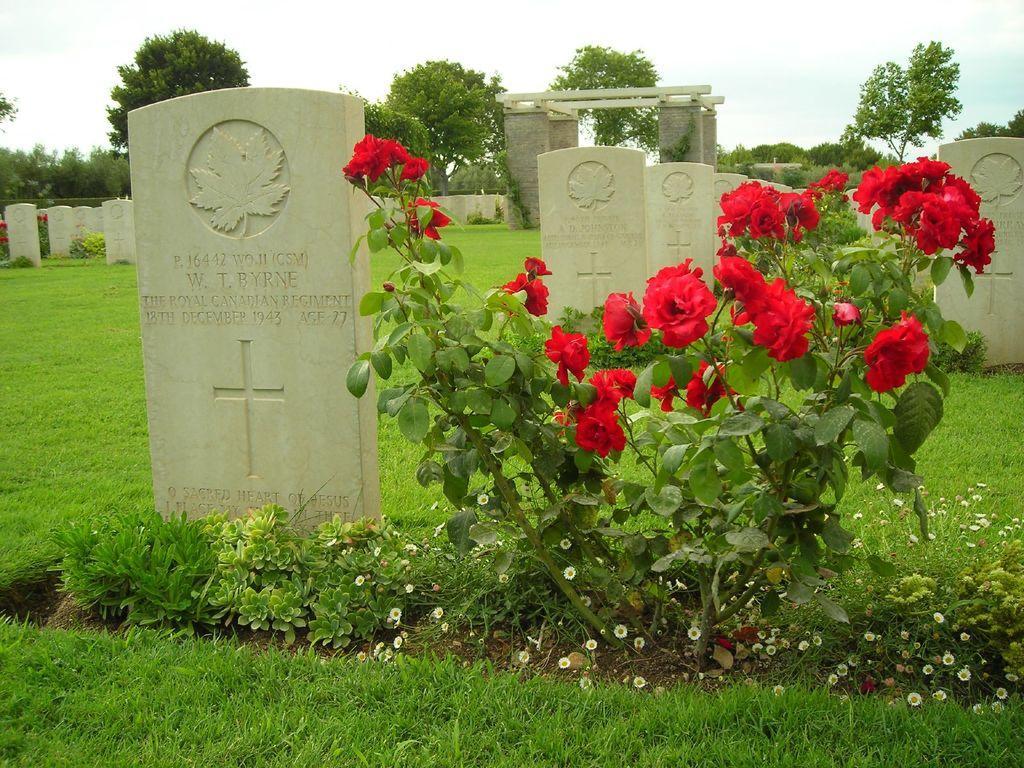Could you give a brief overview of what you see in this image? In this picture I can see trees and few gravestones and plants with flowers and grass on the ground and a cloudy sky. 